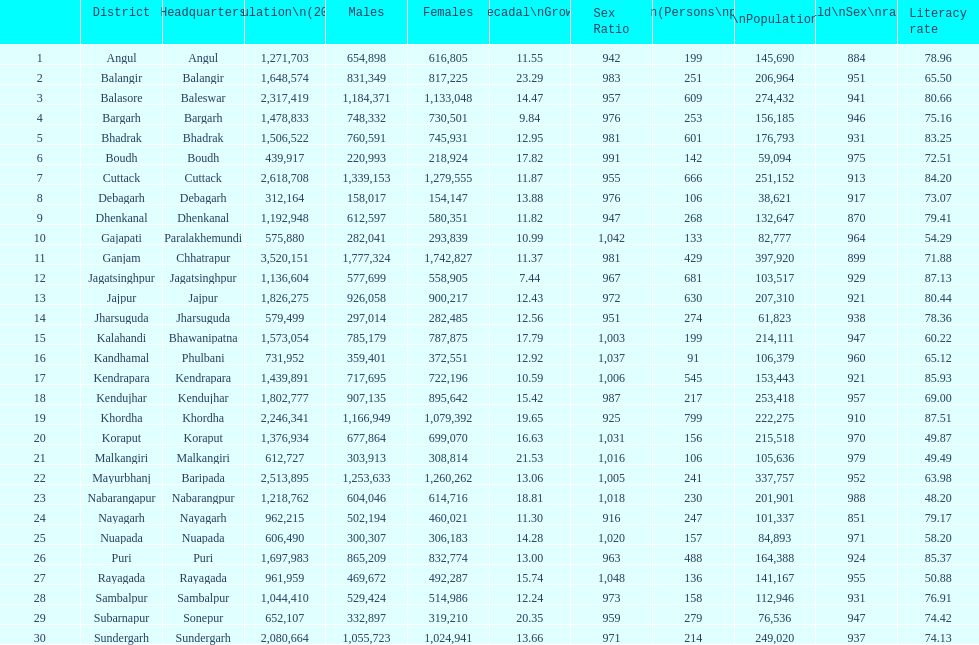Which district had the greatest number of inhabitants per square kilometer? Khordha. 